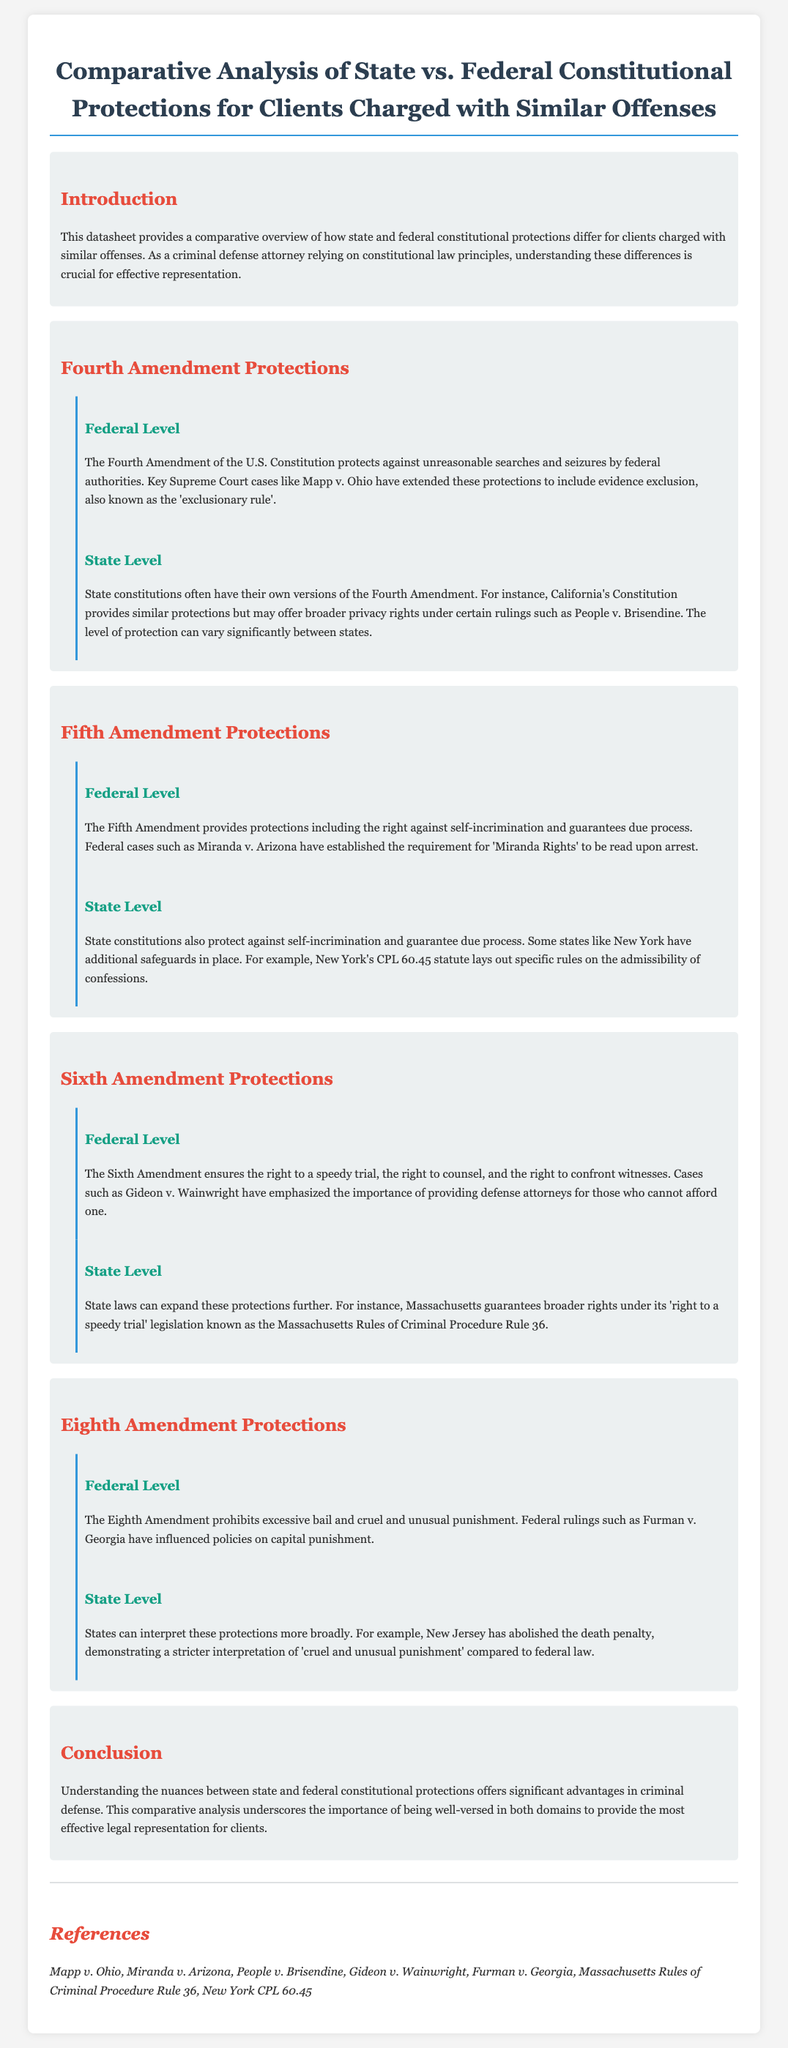What is the main topic of the datasheet? The main topic is a comparative overview of state vs. federal constitutional protections for clients charged with similar offenses.
Answer: Comparative overview of state vs. federal constitutional protections Which amendment protects against unreasonable searches and seizures? The Fourth Amendment of the U.S. Constitution protects against unreasonable searches and seizures.
Answer: Fourth Amendment What case established the requirement for 'Miranda Rights'? Miranda v. Arizona established the requirement for 'Miranda Rights' to be read upon arrest.
Answer: Miranda v. Arizona Which state's constitution provides broader privacy rights under certain rulings? California's Constitution provides broader privacy rights under certain rulings.
Answer: California What is the reference for the right to a speedy trial in Massachusetts? Massachusetts Rules of Criminal Procedure Rule 36 is the reference for the right to a speedy trial in Massachusetts.
Answer: Massachusetts Rules of Criminal Procedure Rule 36 Which state has abolished the death penalty? New Jersey has abolished the death penalty.
Answer: New Jersey What protection does the Eighth Amendment provide? The Eighth Amendment prohibits excessive bail and cruel and unusual punishment.
Answer: Prohibits excessive bail and cruel and unusual punishment How do state laws typically compare with federal protections? State laws can sometimes expand protections further than federal laws.
Answer: Expand protections further than federal laws 